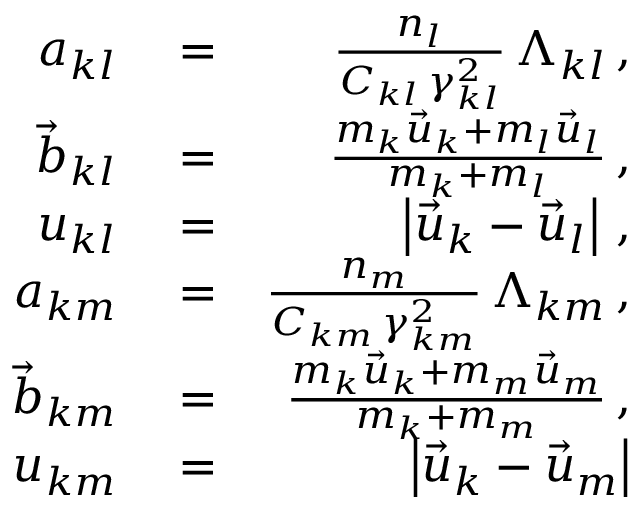Convert formula to latex. <formula><loc_0><loc_0><loc_500><loc_500>\begin{array} { r l r } { a _ { k l } } & = } & { \frac { n _ { l } } { C _ { k l } \, \gamma _ { k l } ^ { 2 } } \, \Lambda _ { k l } \, , } \\ { \vec { b } _ { k l } } & = } & { \frac { m _ { k } \vec { u } _ { k } + m _ { l } \vec { u } _ { l } } { m _ { k } + m _ { l } } \, , } \\ { u _ { k l } } & = } & { \left | \vec { u } _ { k } - \vec { u } _ { l } \right | \, , } \\ { a _ { k m } } & = } & { \frac { n _ { m } } { C _ { k m } \, \gamma _ { k m } ^ { 2 } } \, \Lambda _ { k m } \, , } \\ { \vec { b } _ { k m } } & = } & { \frac { m _ { k } \vec { u } _ { k } + m _ { m } \vec { u } _ { m } } { m _ { k } + m _ { m } } \, , } \\ { u _ { k m } } & = } & { \left | \vec { u } _ { k } - \vec { u } _ { m } \right | } \end{array}</formula> 